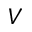Convert formula to latex. <formula><loc_0><loc_0><loc_500><loc_500>V</formula> 